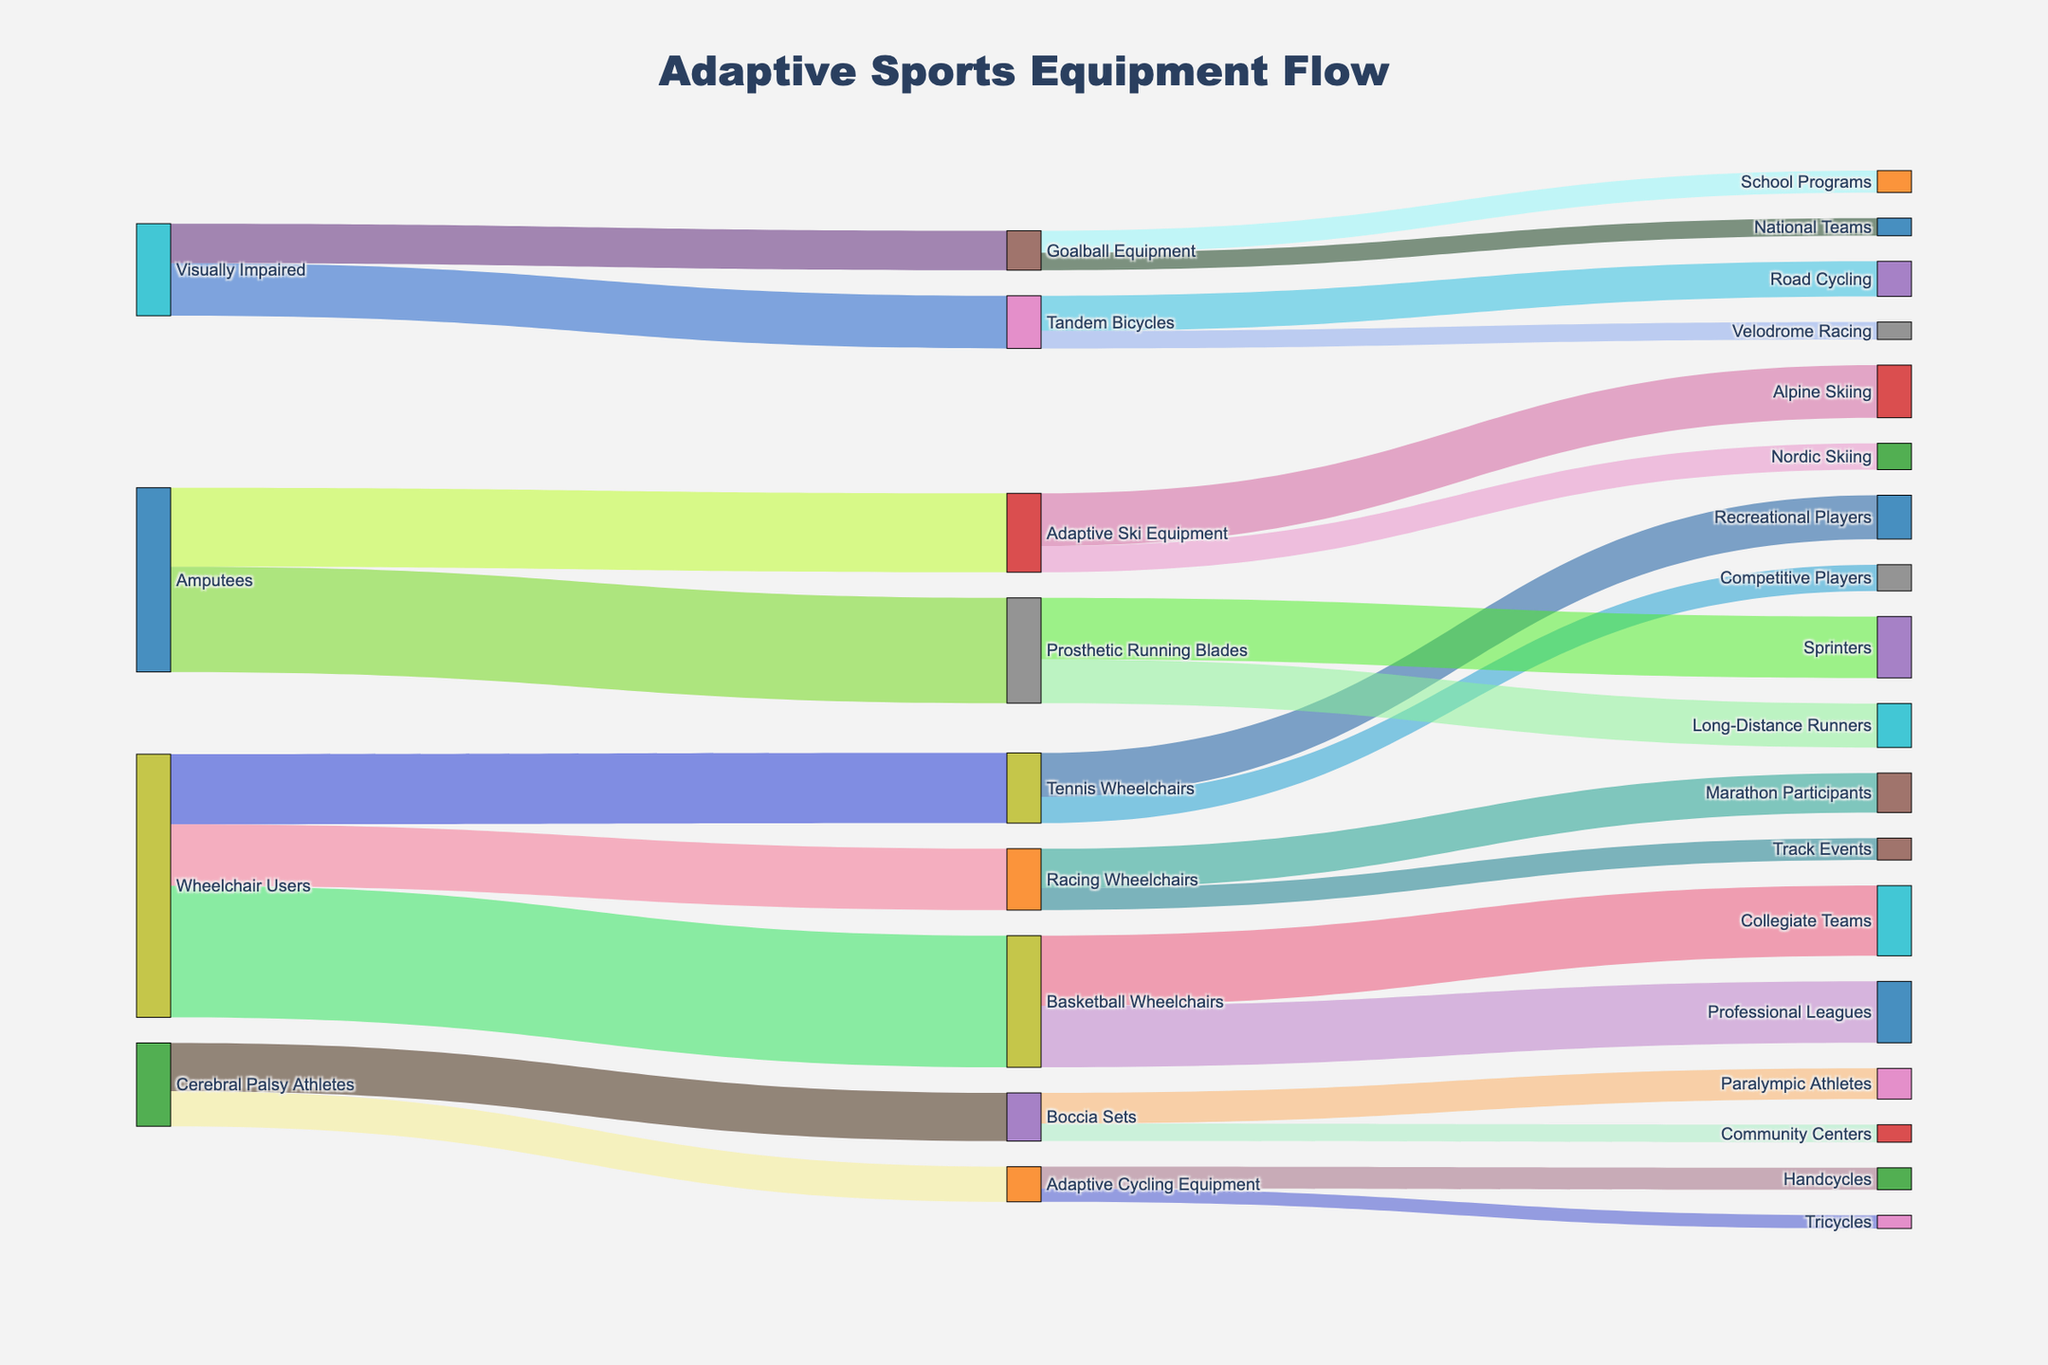Which adaptive sports equipment is most popular among Wheelchair Users? To answer this, observe the flow from "Wheelchair Users" to the different types of equipment. The largest flow indicates popularity, which is "Basketball Wheelchairs" with a value of 150.
Answer: Basketball Wheelchairs What type of sports equipment do Amputees prefer the most? Look at the flows originating from "Amputees" and compare their values. The largest flow is towards "Prosthetic Running Blades" with a value of 120.
Answer: Prosthetic Running Blades What is the total number of visually impaired athletes involved in tandem bicycling and goalball? Add the values of "Tandem Bicycles" and "Goalball Equipment" sourced from "Visually Impaired". These values are 60 and 45, respectively. So, the total is 60 + 45 = 105.
Answer: 105 Which category of athletes uses the most varied types of adaptive sports equipment? Examine the number of unique targets for each source category. "Wheelchair Users" have the most varied types with connections to Basketball Wheelchairs, Tennis Wheelchairs, and Racing Wheelchairs (3 types).
Answer: Wheelchair Users Between Track Events and Marathon Participants, which category uses Racing Wheelchairs more? Compare the flow values from "Racing Wheelchairs" to both "Track Events" and "Marathon Participants". "Marathon Participants" have a value of 45, while "Track Events" have 25. Thus, "Marathon Participants" use them more.
Answer: Marathon Participants Which demographic group uses Boccia Sets according to the Sankey diagram? Identify the source linked directly to "Boccia Sets". The source is "Cerebral Palsy Athletes".
Answer: Cerebral Palsy Athletes What is the percentage of visually impaired athletes who choose Tandem Bicycles over Goalball Equipment? First, find the total number of visually impaired athletes (60 + 45 = 105). Then, calculate the percentage for Tandem Bicycles, which is (60/105) * 100 ≈ 57.14%.
Answer: ≈ 57.14% Which adaptive sports equipment category is equally preferred by both collegiate teams and professional leagues? Check the links between equipment and end categories for values that match. "Basketball Wheelchairs" flows equally to "Collegiate Teams" and "Professional Leagues" both having values of 80 and 70. Therefore, no equipment is equally preferred.
Answer: None What is the least popular piece of equipment among the different adaptive sports categories? Compare the lowest values among the adaptive sports equipment. The smallest value is 15 for "Tricycles" under "Adaptive Cycling Equipment".
Answer: Tricycles How many athletes use adaptive equipment for skiing (both Alpine and Nordic)? Sum the values under "Adaptive Ski Equipment" flows. Values are 60 for Alpine Skiing and 30 for Nordic Skiing. So, 60 + 30 = 90.
Answer: 90 